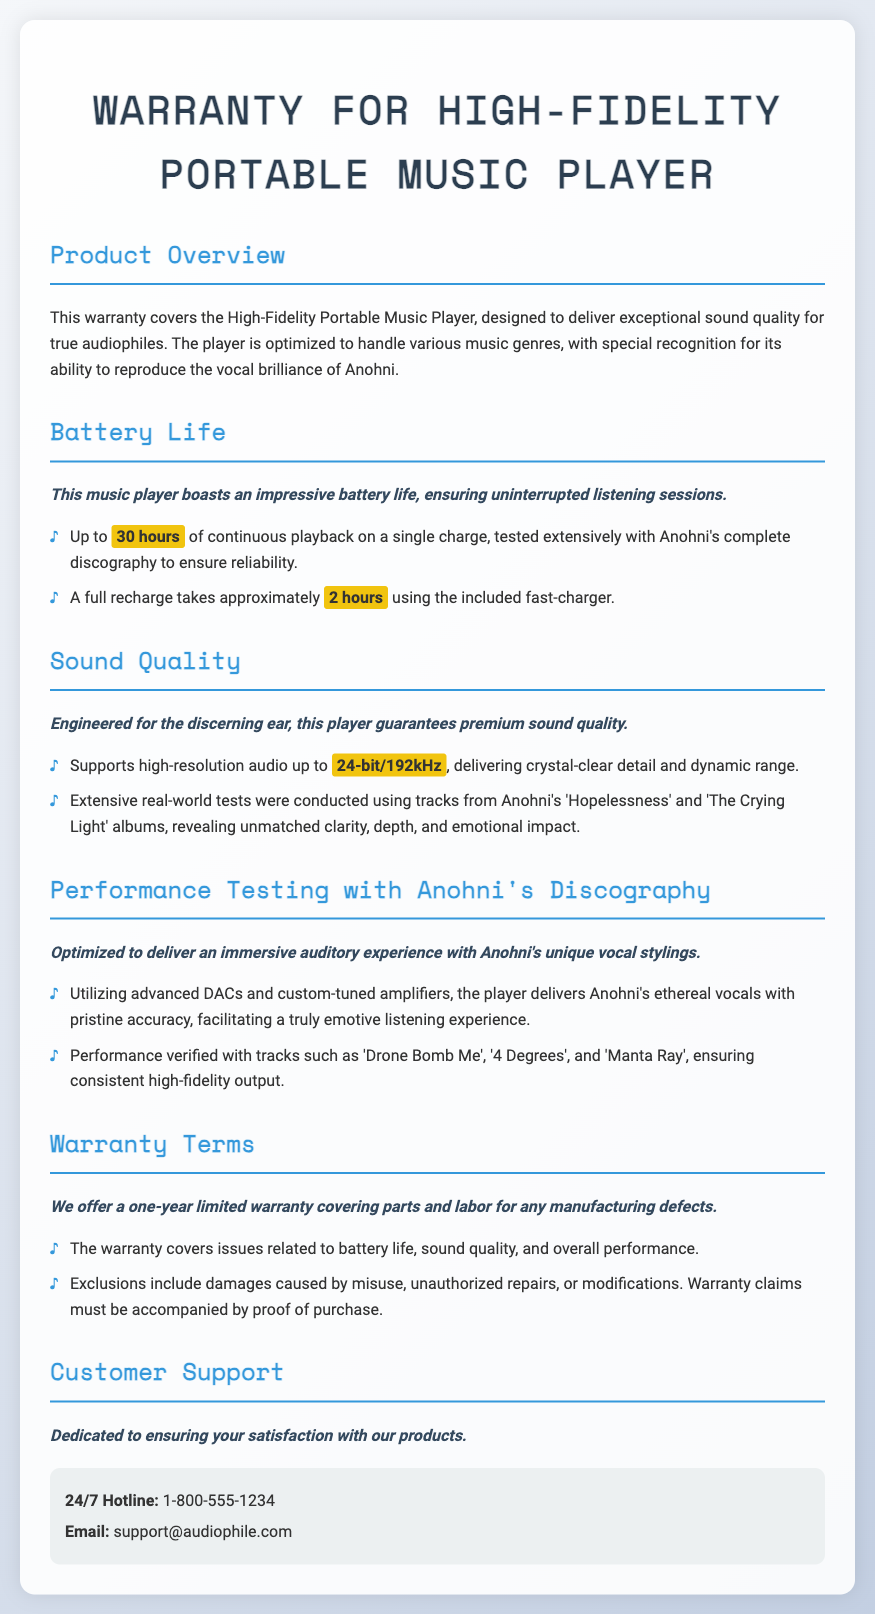What is the maximum battery life of the music player? The maximum battery life is detailed in the Battery Life section, which mentions "30 hours" of continuous playback.
Answer: 30 hours How long does it take to fully recharge the player? The recharge time is specified in the Battery Life section and is stated as "2 hours" using the included fast-charger.
Answer: 2 hours What audio resolution does the player support? The Sound Quality section indicates that the player supports "24-bit/192kHz" high-resolution audio.
Answer: 24-bit/192kHz Which Anohni albums were used for performance testing? The Performance Testing section lists the albums used for testing, specifically mentioning "Hopelessness" and "The Crying Light."
Answer: Hopelessness and The Crying Light What type of warranty is offered? The Warranty Terms section outlines the type of warranty, stating it as a "one-year limited warranty."
Answer: one-year limited warranty What issues does the warranty cover? The Warranty Terms section provides details, stating that the warranty covers "issues related to battery life, sound quality, and overall performance."
Answer: battery life, sound quality, and overall performance What is the 24/7 hotline for customer support? The Customer Support section provides the hotline number as indicated in the contact information.
Answer: 1-800-555-1234 What types of damages are excluded from the warranty? The Warranty Terms section clarifies exclusions, mentioning "damages caused by misuse, unauthorized repairs, or modifications."
Answer: misuse, unauthorized repairs, or modifications 